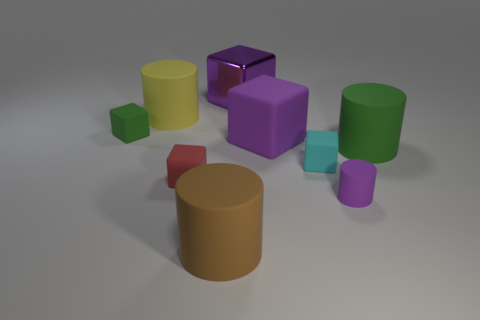Subtract all big yellow rubber cylinders. How many cylinders are left? 3 Add 1 cylinders. How many objects exist? 10 Subtract all brown cylinders. How many cylinders are left? 3 Subtract all cylinders. How many objects are left? 5 Subtract 3 cubes. How many cubes are left? 2 Subtract all red cylinders. How many purple cubes are left? 2 Subtract all red cylinders. Subtract all purple balls. How many cylinders are left? 4 Subtract all small blue cylinders. Subtract all tiny green objects. How many objects are left? 8 Add 3 small red cubes. How many small red cubes are left? 4 Add 2 big cyan cubes. How many big cyan cubes exist? 2 